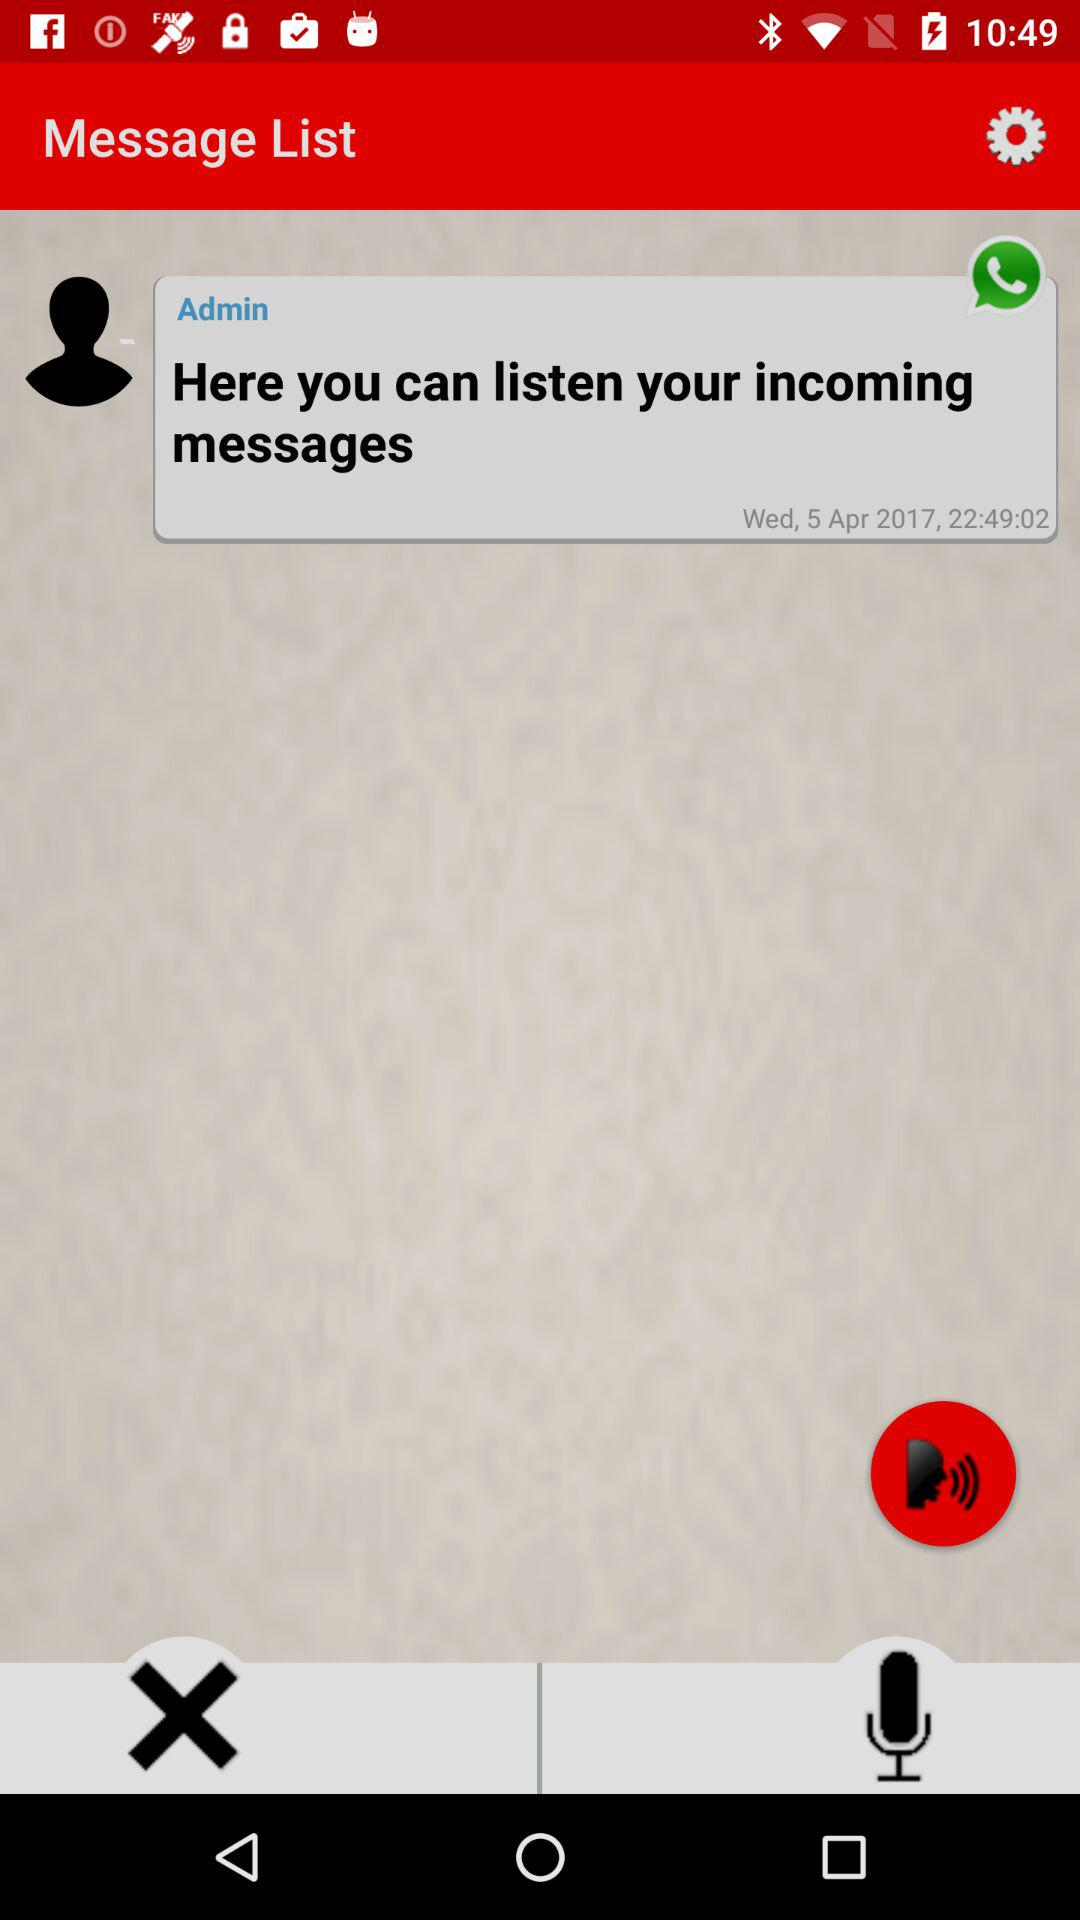How old is "Admin"?
When the provided information is insufficient, respond with <no answer>. <no answer> 